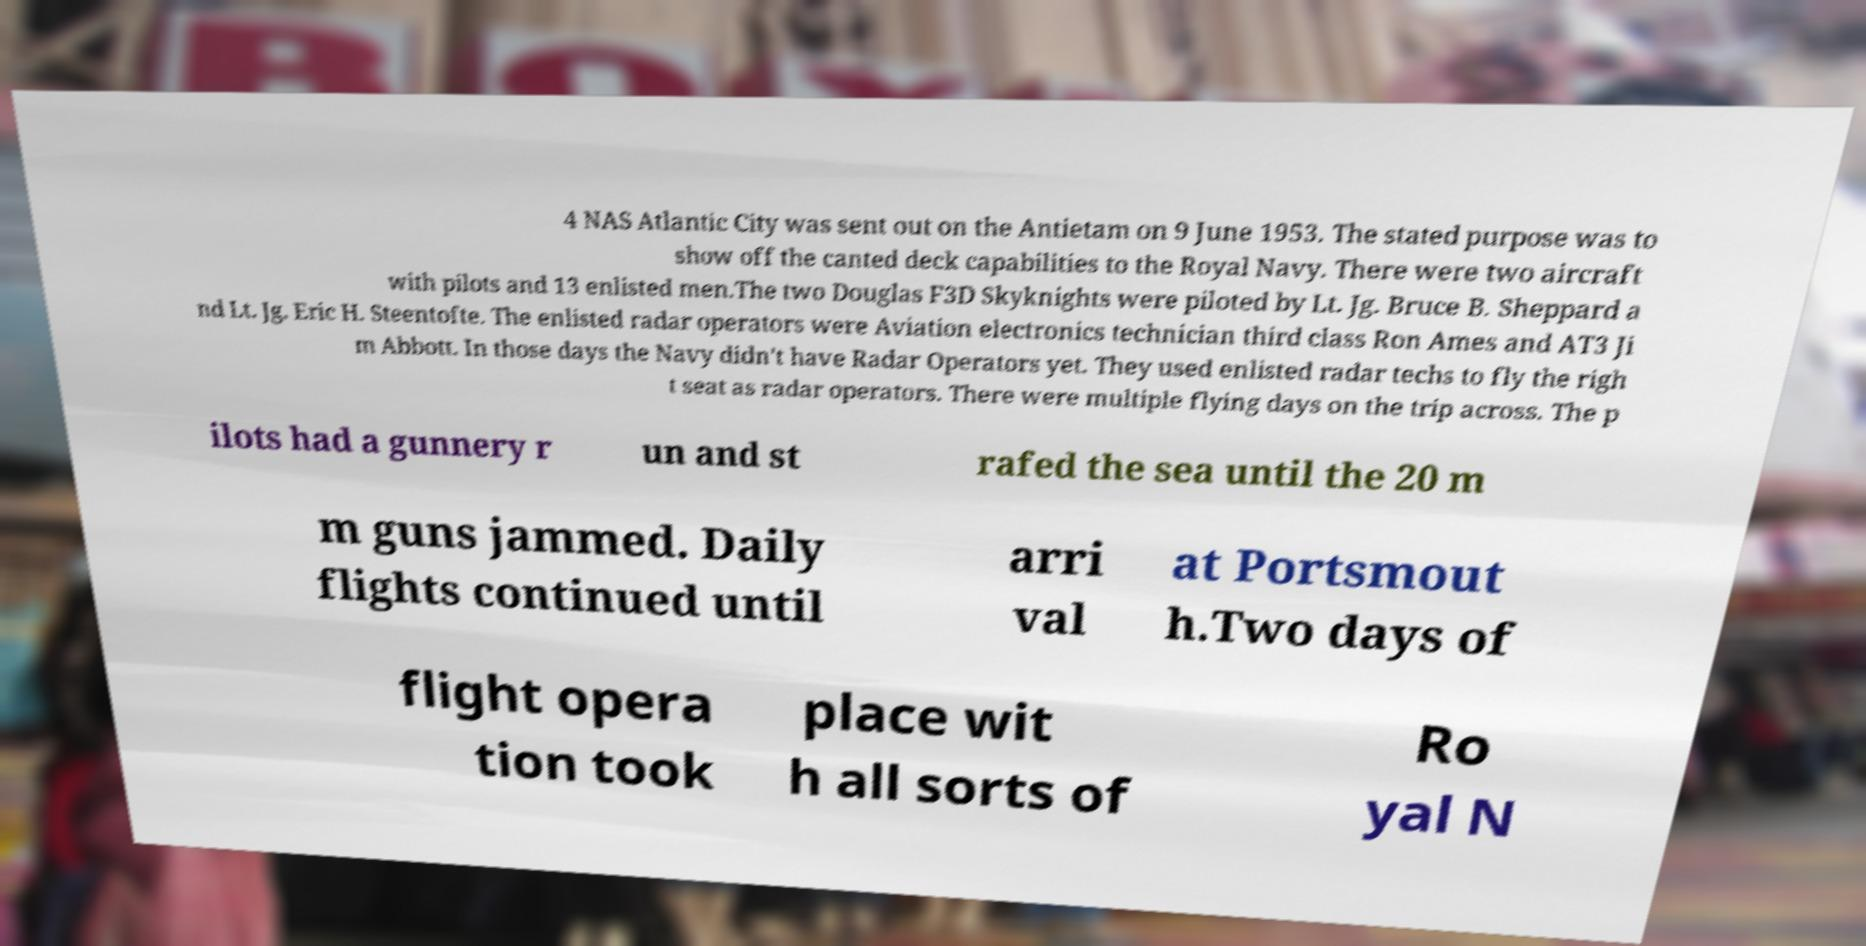Can you accurately transcribe the text from the provided image for me? 4 NAS Atlantic City was sent out on the Antietam on 9 June 1953. The stated purpose was to show off the canted deck capabilities to the Royal Navy. There were two aircraft with pilots and 13 enlisted men.The two Douglas F3D Skyknights were piloted by Lt. Jg. Bruce B. Sheppard a nd Lt. Jg. Eric H. Steentofte. The enlisted radar operators were Aviation electronics technician third class Ron Ames and AT3 Ji m Abbott. In those days the Navy didn't have Radar Operators yet. They used enlisted radar techs to fly the righ t seat as radar operators. There were multiple flying days on the trip across. The p ilots had a gunnery r un and st rafed the sea until the 20 m m guns jammed. Daily flights continued until arri val at Portsmout h.Two days of flight opera tion took place wit h all sorts of Ro yal N 